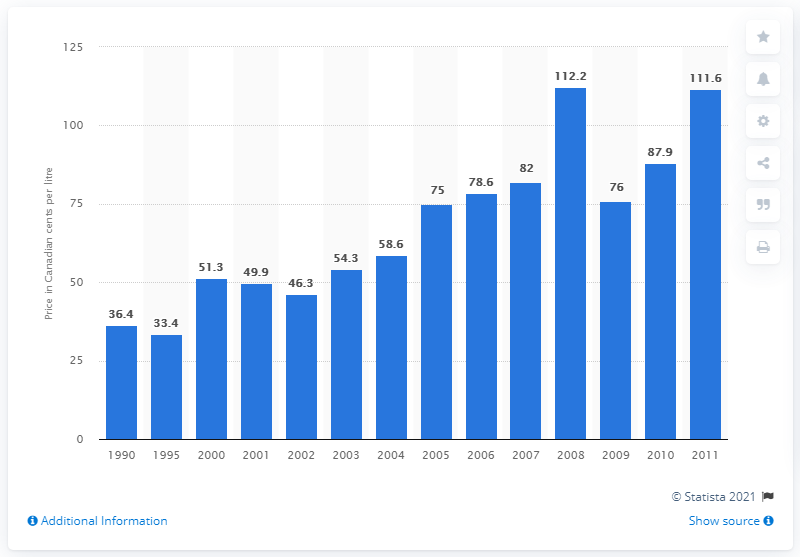Point out several critical features in this image. In the year 2000, the price per litre of home heating oil in Montreal was 51.3 cents. 